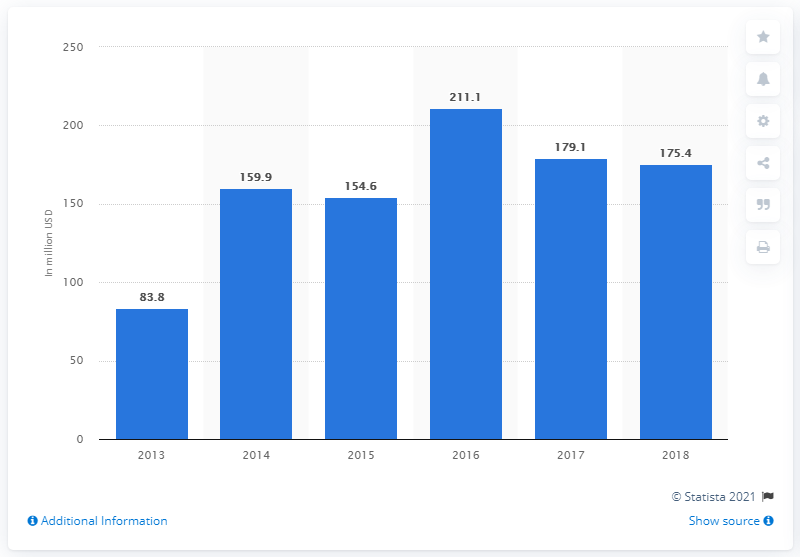Can you tell me more about the trend in reward-based crowdfunding in the US from 2013 to 2018? Certainly. The bar chart shows a significant upward trend in the total transaction value of reward-based crowdfunding in the US from 2013 to 2018. Starting at $83.8 million in 2013, there is a noticeable increase each year until 2016 where it peaks at $211.1 million. After 2016, there's a slight dip, with the amounts for 2017 and 2018 being $179.1 million and $175.4 million respectively. 